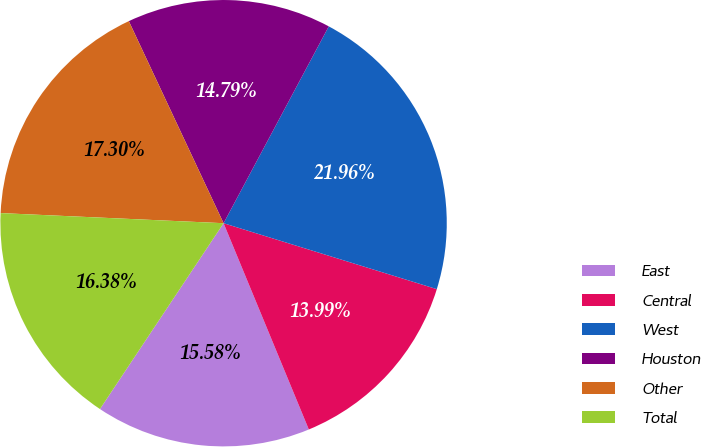Convert chart to OTSL. <chart><loc_0><loc_0><loc_500><loc_500><pie_chart><fcel>East<fcel>Central<fcel>West<fcel>Houston<fcel>Other<fcel>Total<nl><fcel>15.58%<fcel>13.99%<fcel>21.96%<fcel>14.79%<fcel>17.3%<fcel>16.38%<nl></chart> 